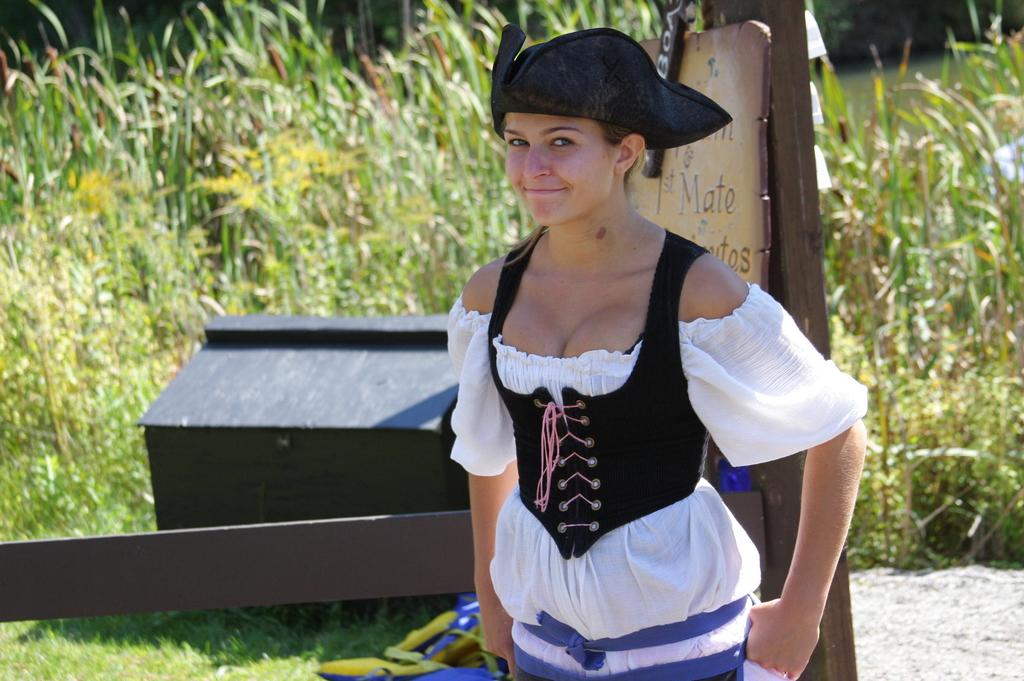What is one word written on the sign behind the girl?
Your answer should be compact. Mate. 